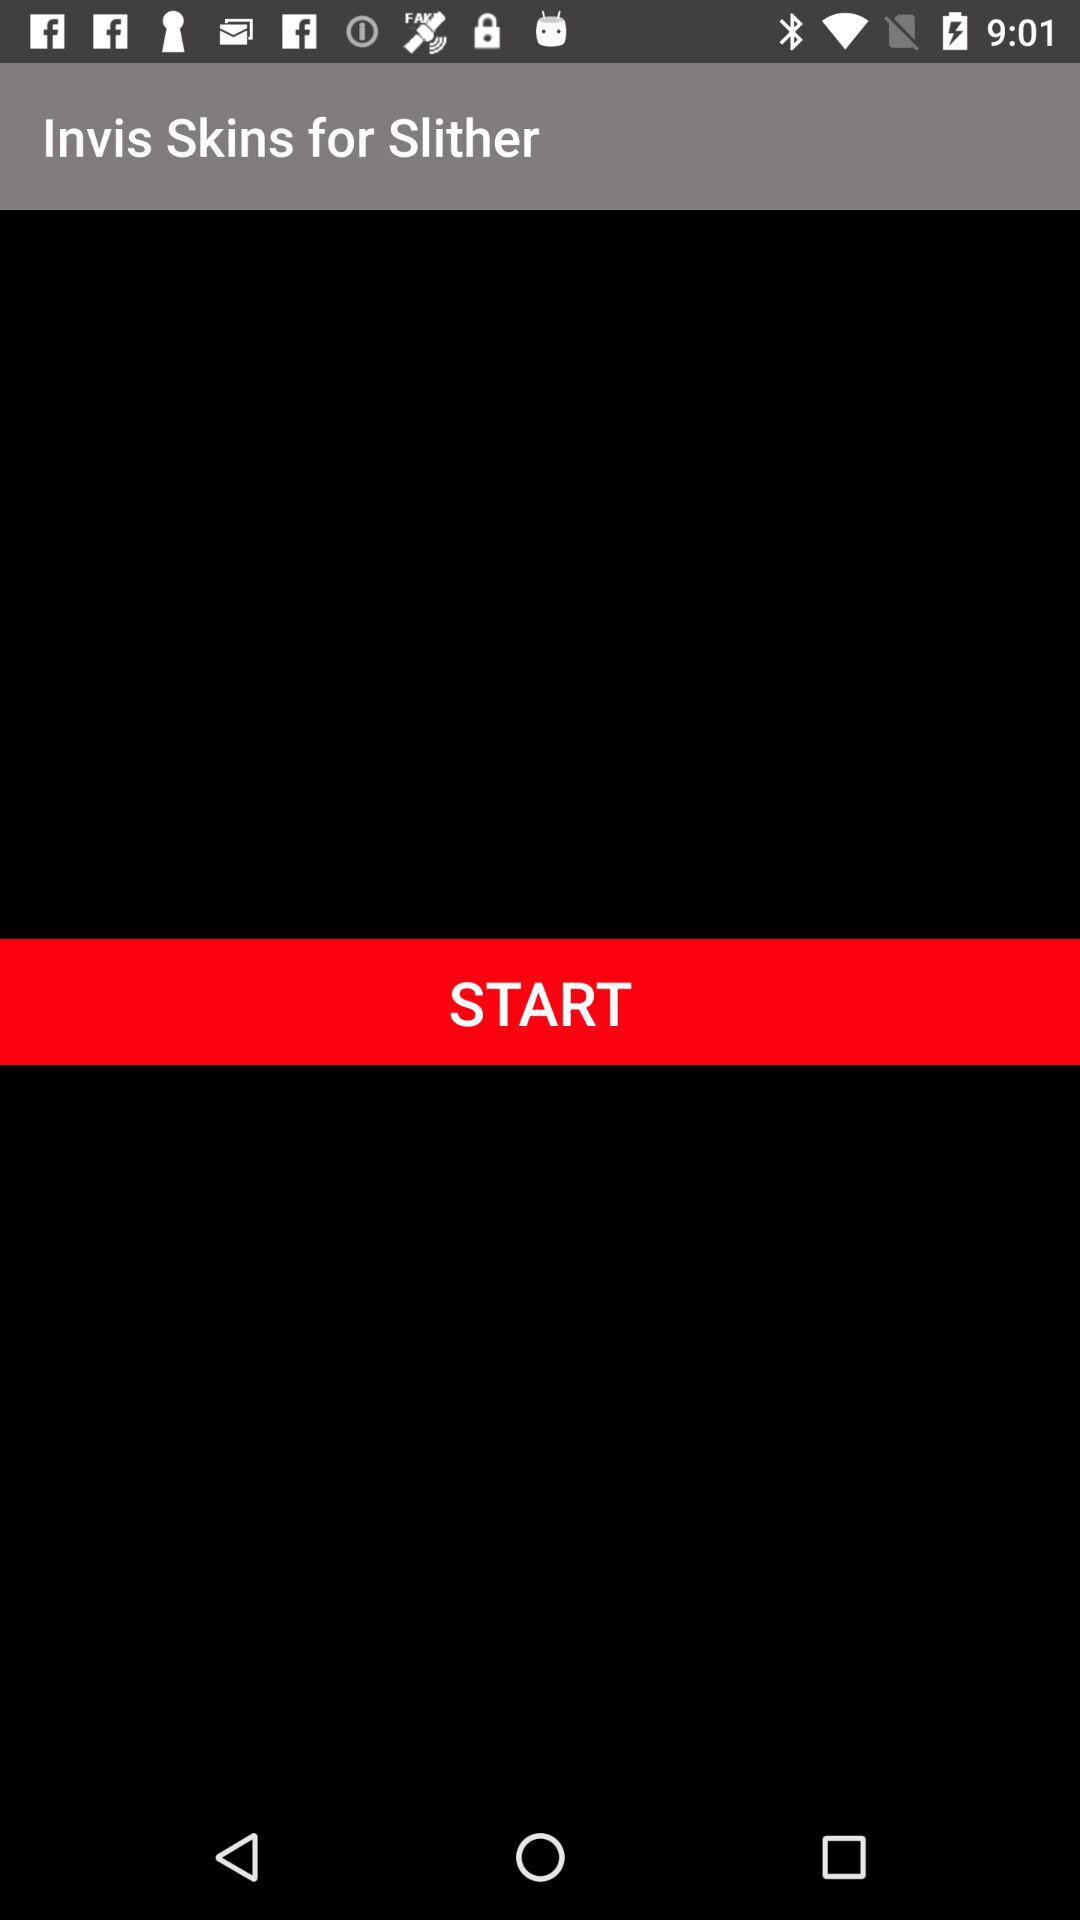What is the name of the application? The name of the application is "Invis Skins for Slither". 